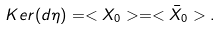<formula> <loc_0><loc_0><loc_500><loc_500>K e r ( d \eta ) = < X _ { 0 } > = < \bar { X } _ { 0 } > .</formula> 